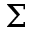<formula> <loc_0><loc_0><loc_500><loc_500>\Sigma</formula> 